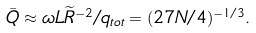<formula> <loc_0><loc_0><loc_500><loc_500>\bar { Q } \approx \omega L \widetilde { R } ^ { - 2 } / q _ { t o t } = ( 2 7 N / 4 ) ^ { - 1 / 3 } .</formula> 